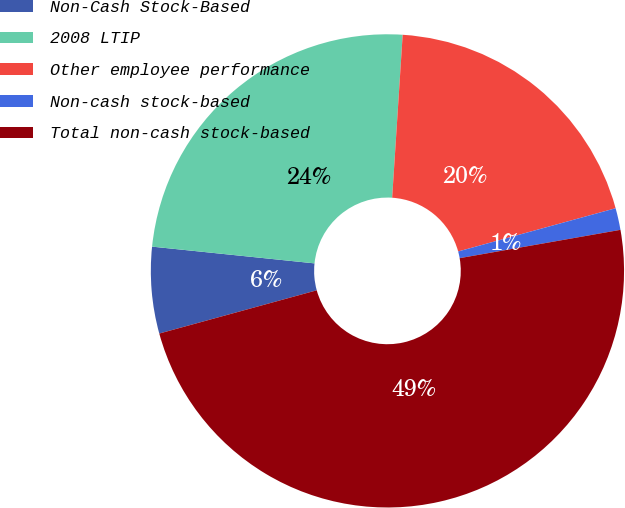Convert chart to OTSL. <chart><loc_0><loc_0><loc_500><loc_500><pie_chart><fcel>Non-Cash Stock-Based<fcel>2008 LTIP<fcel>Other employee performance<fcel>Non-cash stock-based<fcel>Total non-cash stock-based<nl><fcel>5.9%<fcel>24.39%<fcel>19.71%<fcel>1.49%<fcel>48.51%<nl></chart> 